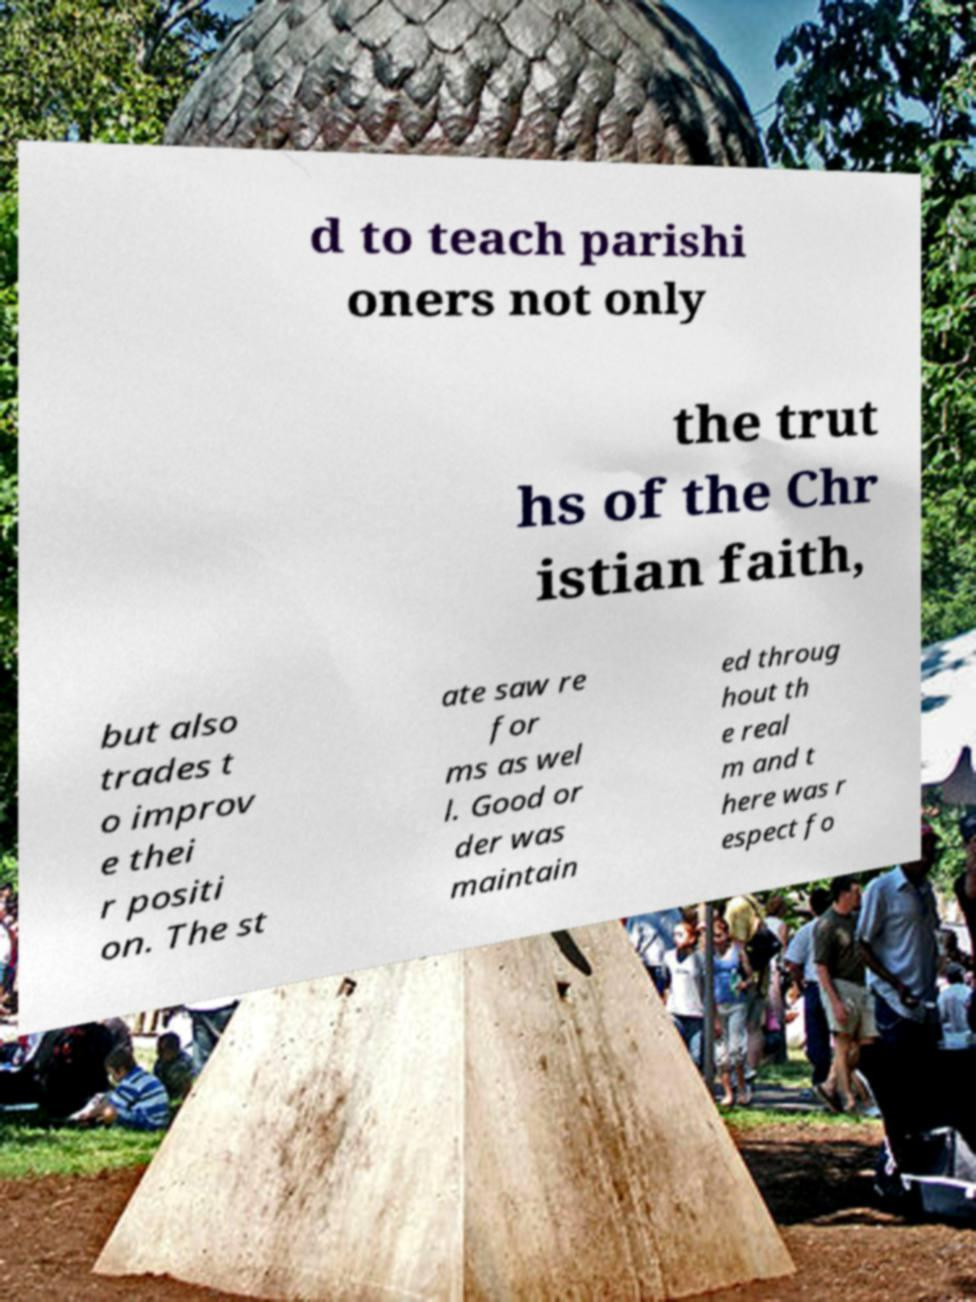Can you accurately transcribe the text from the provided image for me? d to teach parishi oners not only the trut hs of the Chr istian faith, but also trades t o improv e thei r positi on. The st ate saw re for ms as wel l. Good or der was maintain ed throug hout th e real m and t here was r espect fo 